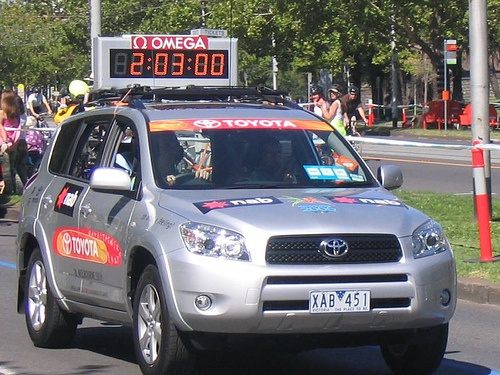Describe the objects in this image and their specific colors. I can see car in darkgray, gray, and lavender tones, clock in darkgray, black, maroon, salmon, and navy tones, people in darkgray, black, gray, maroon, and brown tones, people in darkgray, black, darkblue, and gray tones, and people in darkgray, navy, darkblue, and gray tones in this image. 